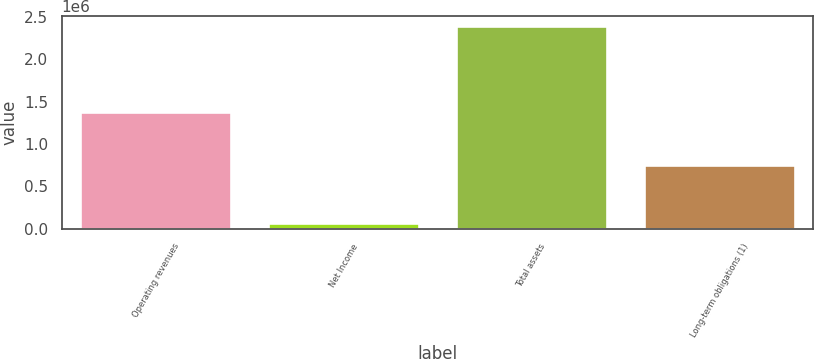Convert chart to OTSL. <chart><loc_0><loc_0><loc_500><loc_500><bar_chart><fcel>Operating revenues<fcel>Net Income<fcel>Total assets<fcel>Long-term obligations (1)<nl><fcel>1.37401e+06<fcel>72853<fcel>2.38936e+06<fcel>753453<nl></chart> 